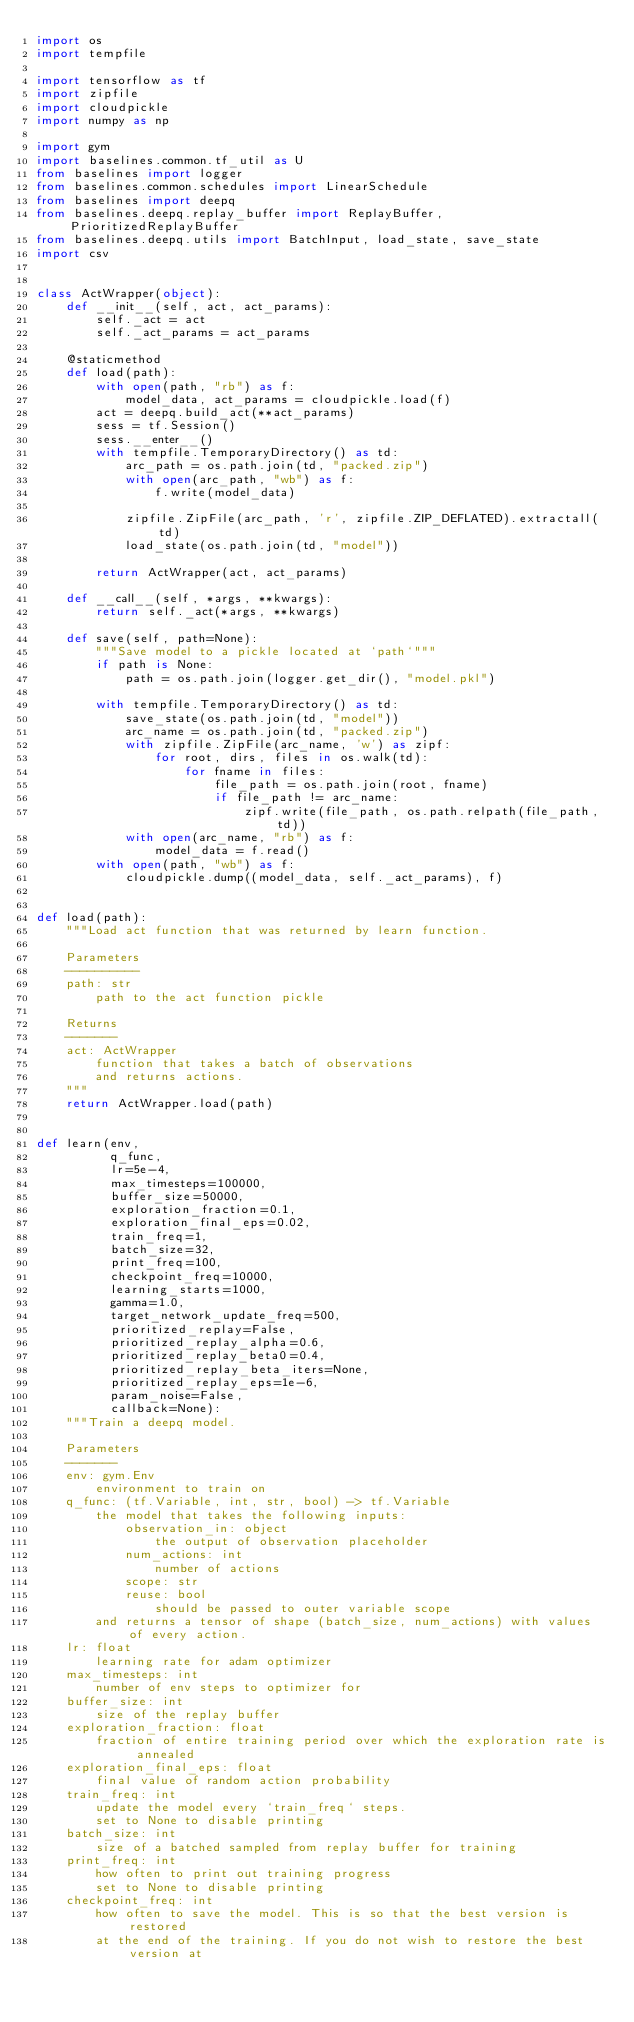<code> <loc_0><loc_0><loc_500><loc_500><_Python_>import os
import tempfile

import tensorflow as tf
import zipfile
import cloudpickle
import numpy as np

import gym
import baselines.common.tf_util as U
from baselines import logger
from baselines.common.schedules import LinearSchedule
from baselines import deepq
from baselines.deepq.replay_buffer import ReplayBuffer, PrioritizedReplayBuffer
from baselines.deepq.utils import BatchInput, load_state, save_state
import csv


class ActWrapper(object):
    def __init__(self, act, act_params):
        self._act = act
        self._act_params = act_params

    @staticmethod
    def load(path):
        with open(path, "rb") as f:
            model_data, act_params = cloudpickle.load(f)
        act = deepq.build_act(**act_params)
        sess = tf.Session()
        sess.__enter__()
        with tempfile.TemporaryDirectory() as td:
            arc_path = os.path.join(td, "packed.zip")
            with open(arc_path, "wb") as f:
                f.write(model_data)

            zipfile.ZipFile(arc_path, 'r', zipfile.ZIP_DEFLATED).extractall(td)
            load_state(os.path.join(td, "model"))

        return ActWrapper(act, act_params)

    def __call__(self, *args, **kwargs):
        return self._act(*args, **kwargs)

    def save(self, path=None):
        """Save model to a pickle located at `path`"""
        if path is None:
            path = os.path.join(logger.get_dir(), "model.pkl")

        with tempfile.TemporaryDirectory() as td:
            save_state(os.path.join(td, "model"))
            arc_name = os.path.join(td, "packed.zip")
            with zipfile.ZipFile(arc_name, 'w') as zipf:
                for root, dirs, files in os.walk(td):
                    for fname in files:
                        file_path = os.path.join(root, fname)
                        if file_path != arc_name:
                            zipf.write(file_path, os.path.relpath(file_path, td))
            with open(arc_name, "rb") as f:
                model_data = f.read()
        with open(path, "wb") as f:
            cloudpickle.dump((model_data, self._act_params), f)


def load(path):
    """Load act function that was returned by learn function.

    Parameters
    ----------
    path: str
        path to the act function pickle

    Returns
    -------
    act: ActWrapper
        function that takes a batch of observations
        and returns actions.
    """
    return ActWrapper.load(path)


def learn(env,
          q_func,
          lr=5e-4,
          max_timesteps=100000,
          buffer_size=50000,
          exploration_fraction=0.1,
          exploration_final_eps=0.02,
          train_freq=1,
          batch_size=32,
          print_freq=100,
          checkpoint_freq=10000,
          learning_starts=1000,
          gamma=1.0,
          target_network_update_freq=500,
          prioritized_replay=False,
          prioritized_replay_alpha=0.6,
          prioritized_replay_beta0=0.4,
          prioritized_replay_beta_iters=None,
          prioritized_replay_eps=1e-6,
          param_noise=False,
          callback=None):
    """Train a deepq model.

    Parameters
    -------
    env: gym.Env
        environment to train on
    q_func: (tf.Variable, int, str, bool) -> tf.Variable
        the model that takes the following inputs:
            observation_in: object
                the output of observation placeholder
            num_actions: int
                number of actions
            scope: str
            reuse: bool
                should be passed to outer variable scope
        and returns a tensor of shape (batch_size, num_actions) with values of every action.
    lr: float
        learning rate for adam optimizer
    max_timesteps: int
        number of env steps to optimizer for
    buffer_size: int
        size of the replay buffer
    exploration_fraction: float
        fraction of entire training period over which the exploration rate is annealed
    exploration_final_eps: float
        final value of random action probability
    train_freq: int
        update the model every `train_freq` steps.
        set to None to disable printing
    batch_size: int
        size of a batched sampled from replay buffer for training
    print_freq: int
        how often to print out training progress
        set to None to disable printing
    checkpoint_freq: int
        how often to save the model. This is so that the best version is restored
        at the end of the training. If you do not wish to restore the best version at</code> 